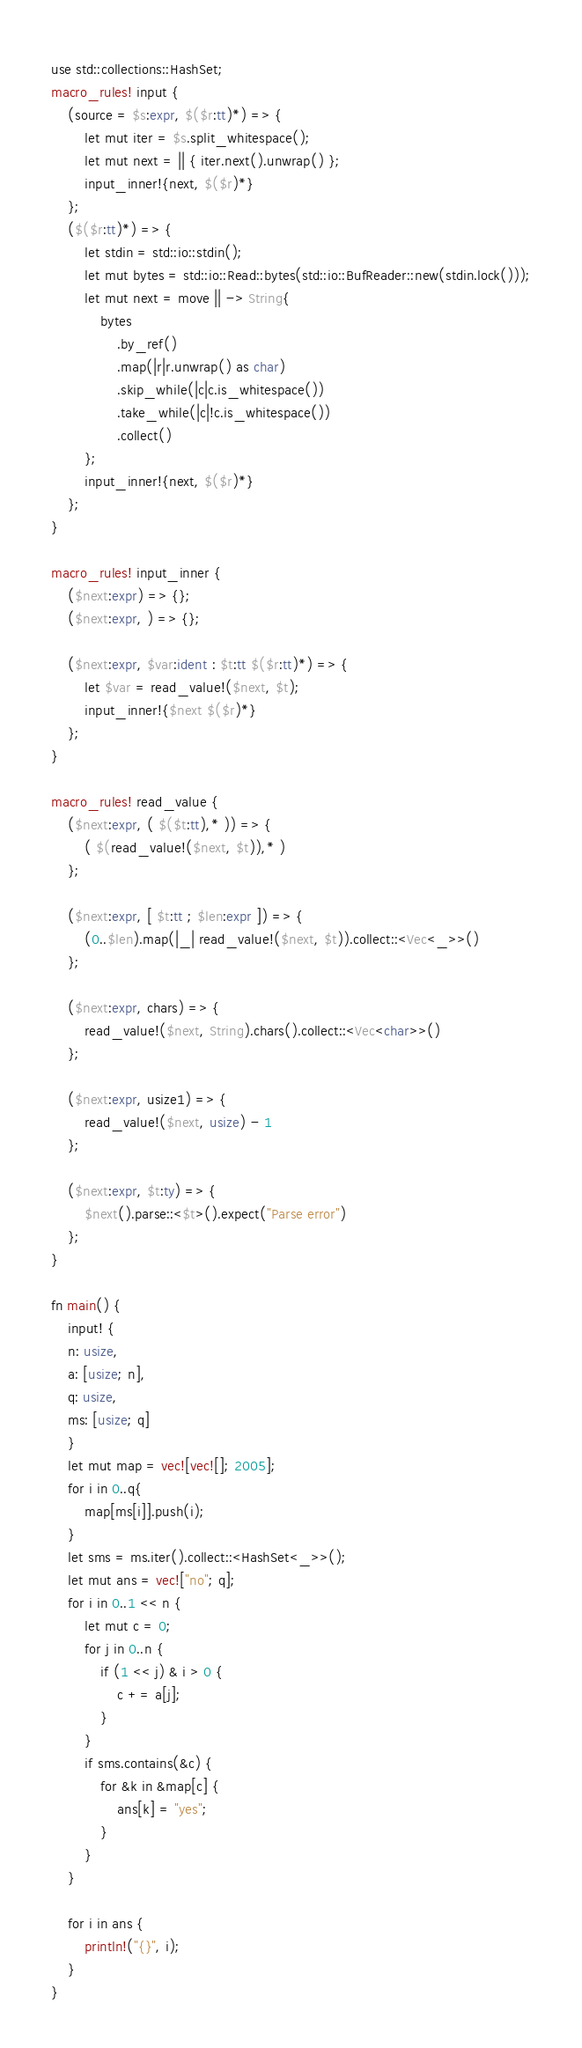<code> <loc_0><loc_0><loc_500><loc_500><_Rust_>use std::collections::HashSet;
macro_rules! input {
    (source = $s:expr, $($r:tt)*) => {
        let mut iter = $s.split_whitespace();
        let mut next = || { iter.next().unwrap() };
        input_inner!{next, $($r)*}
    };
    ($($r:tt)*) => {
        let stdin = std::io::stdin();
        let mut bytes = std::io::Read::bytes(std::io::BufReader::new(stdin.lock()));
        let mut next = move || -> String{
            bytes
                .by_ref()
                .map(|r|r.unwrap() as char)
                .skip_while(|c|c.is_whitespace())
                .take_while(|c|!c.is_whitespace())
                .collect()
        };
        input_inner!{next, $($r)*}
    };
}

macro_rules! input_inner {
    ($next:expr) => {};
    ($next:expr, ) => {};

    ($next:expr, $var:ident : $t:tt $($r:tt)*) => {
        let $var = read_value!($next, $t);
        input_inner!{$next $($r)*}
    };
}

macro_rules! read_value {
    ($next:expr, ( $($t:tt),* )) => {
        ( $(read_value!($next, $t)),* )
    };

    ($next:expr, [ $t:tt ; $len:expr ]) => {
        (0..$len).map(|_| read_value!($next, $t)).collect::<Vec<_>>()
    };

    ($next:expr, chars) => {
        read_value!($next, String).chars().collect::<Vec<char>>()
    };

    ($next:expr, usize1) => {
        read_value!($next, usize) - 1
    };

    ($next:expr, $t:ty) => {
        $next().parse::<$t>().expect("Parse error")
    };
}

fn main() {
    input! {
    n: usize,
    a: [usize; n],
    q: usize,
    ms: [usize; q]
    }
    let mut map = vec![vec![]; 2005];
    for i in 0..q{
        map[ms[i]].push(i);
    }
    let sms = ms.iter().collect::<HashSet<_>>();
    let mut ans = vec!["no"; q];
    for i in 0..1 << n {
        let mut c = 0;
        for j in 0..n {
            if (1 << j) & i > 0 {
                c += a[j];
            }
        }
        if sms.contains(&c) {
            for &k in &map[c] {
                ans[k] = "yes";
            }
        }
    }

    for i in ans {
        println!("{}", i);
    }
}

</code> 